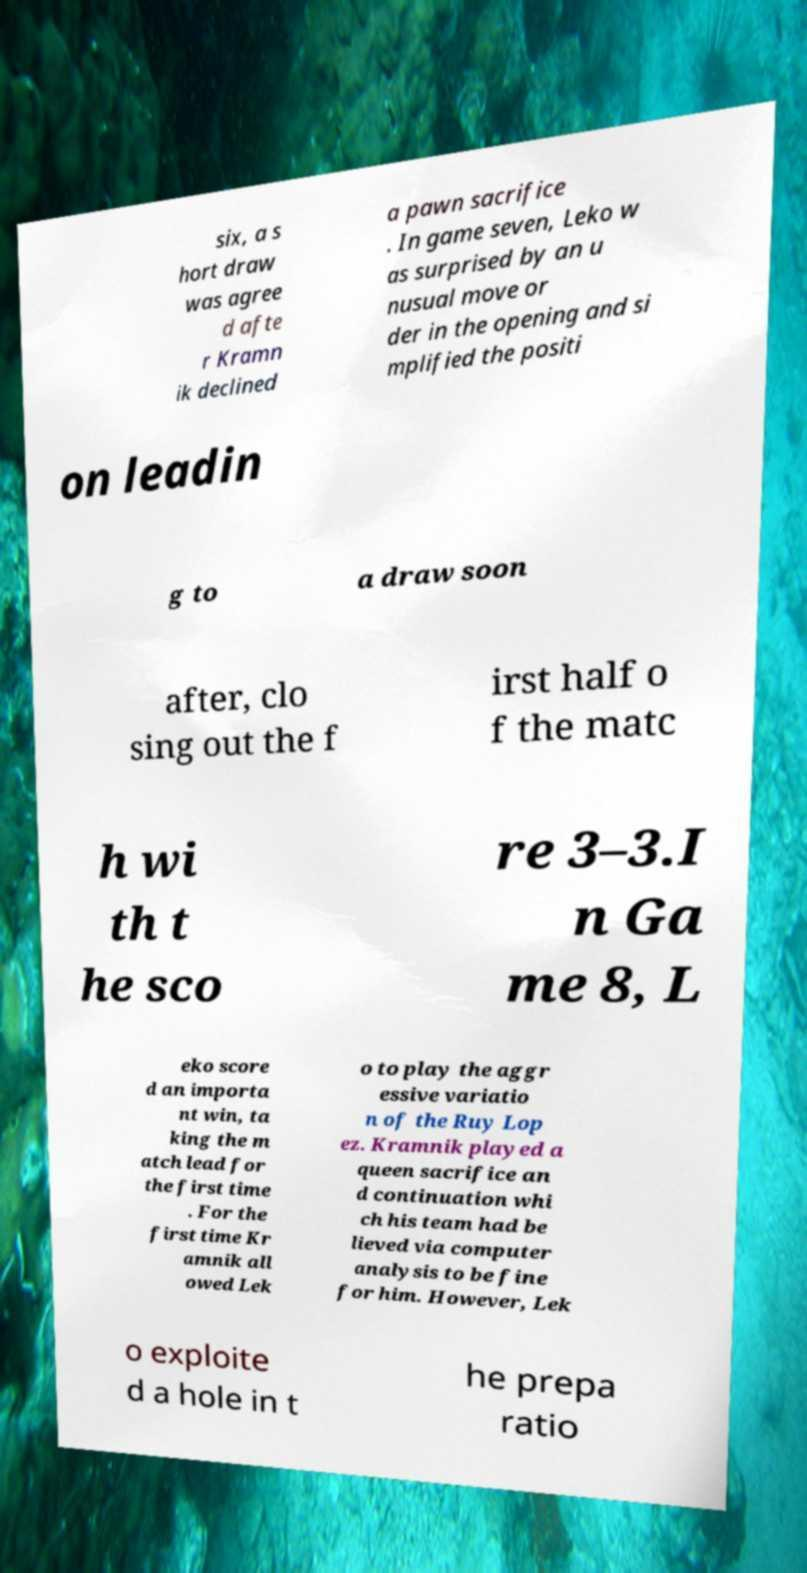There's text embedded in this image that I need extracted. Can you transcribe it verbatim? six, a s hort draw was agree d afte r Kramn ik declined a pawn sacrifice . In game seven, Leko w as surprised by an u nusual move or der in the opening and si mplified the positi on leadin g to a draw soon after, clo sing out the f irst half o f the matc h wi th t he sco re 3–3.I n Ga me 8, L eko score d an importa nt win, ta king the m atch lead for the first time . For the first time Kr amnik all owed Lek o to play the aggr essive variatio n of the Ruy Lop ez. Kramnik played a queen sacrifice an d continuation whi ch his team had be lieved via computer analysis to be fine for him. However, Lek o exploite d a hole in t he prepa ratio 